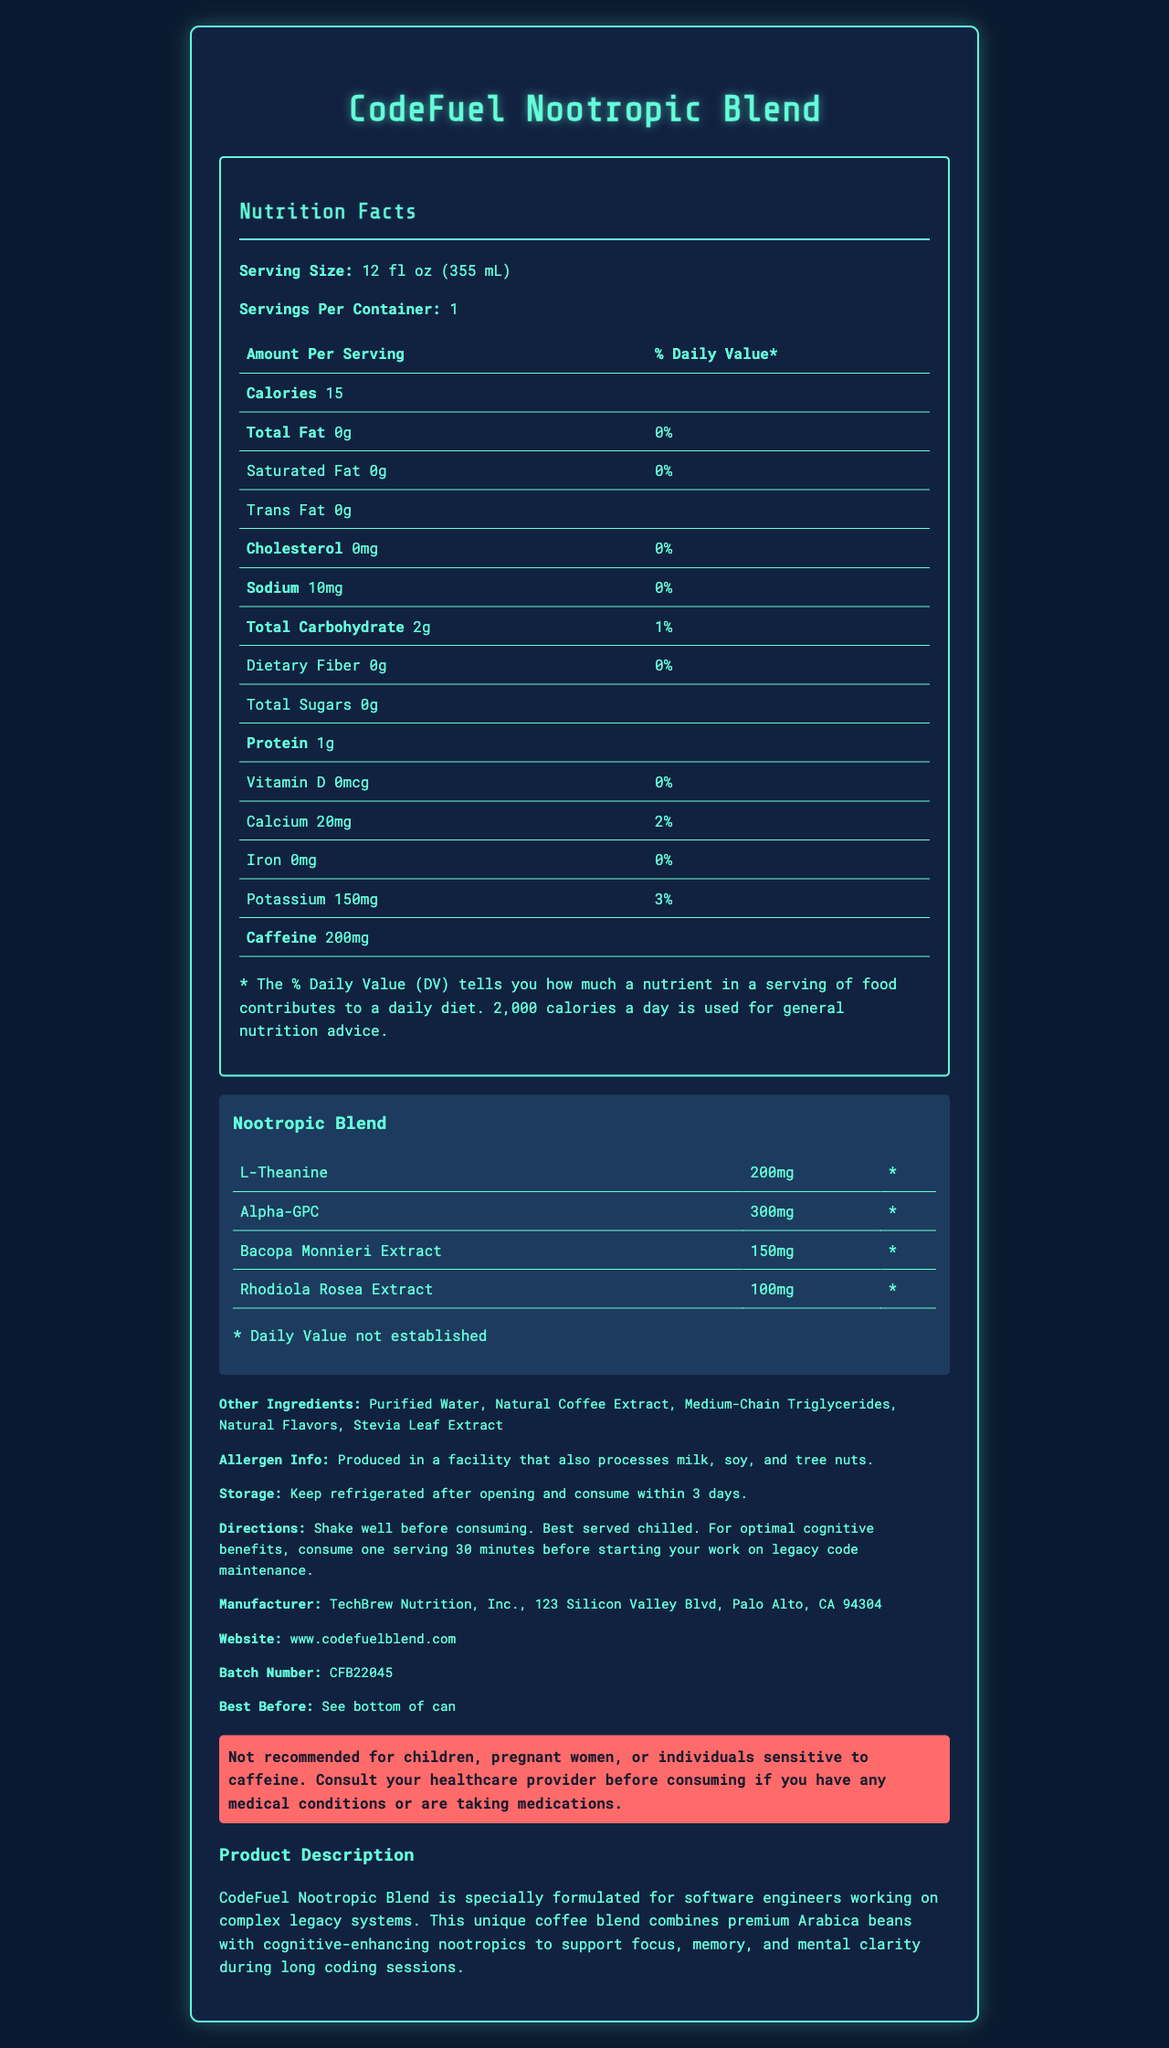what is the serving size? The serving size is stated as "12 fl oz (355 mL)" in the Nutrition Facts section.
Answer: 12 fl oz (355 mL) how many calories are in a serving? The document states that each serving has 15 calories.
Answer: 15 what is the amount of protein per serving? The Nutrition Facts section lists the protein content as 1g per serving.
Answer: 1g how much caffeine is in one serving? The document specifies that each serving contains 200mg of caffeine.
Answer: 200mg what is the sodium content per serving? The sodium content per serving is listed as 10mg in the Nutrition Facts section.
Answer: 10mg what is the daily value percentage for calcium? The Nutrition Facts table lists calcium as providing 2% of the Daily Value.
Answer: 2% which nootropic has the highest amount per serving? A. L-Theanine B. Alpha-GPC C. Bacopa Monnieri Extract D. Rhodiola Rosea Extract The document lists Alpha-GPC as having 300mg per serving, which is the highest amount among the nootropics.
Answer: B. Alpha-GPC which of the following ingredients are present in the CodeFuel Nootropic Blend? A. Purified Water B. Natural Coffee Extract C. Medium-Chain Triglycerides D. All of the above The section on "Other Ingredients" lists Purified Water, Natural Coffee Extract, and Medium-Chain Triglycerides among others.
Answer: D. All of the above is this product recommended for children? The warning section clearly states that the product is "Not recommended for children."
Answer: No how many servings are there per container? The Nutrition Facts indicate that there is 1 serving per container.
Answer: 1 what is the main idea of this document? The document provides detailed information on the nutritional content, ingredient list, and additional product information of the CodeFuel Nootropic Blend, highlighting its benefits for software engineers.
Answer: Description of the nutrition facts and ingredients of CodeFuel Nootropic Blend, a coffee formulated with cognitive-enhancing nootropics for software engineers. where can I find the best before date? The "Best Before" information is noted as being located on the bottom of the can.
Answer: See bottom of can what percentage of the daily value of dietary fiber does one serving provide? The Dietary Fiber section shows a 0% Daily Value for dietary fiber.
Answer: 0% who is the manufacturer of this product? The document lists TechBrew Nutrition, Inc. as the manufacturer.
Answer: TechBrew Nutrition, Inc. does this product contain any sugar? The Nutrition Facts section lists Total Sugars as 0g, indicating no sugar content in the product.
Answer: No how much Bacopa Monnieri Extract is in a serving? The document specifies that each serving contains 150mg of Bacopa Monnieri Extract.
Answer: 150mg what is the address of the manufacturer? The manufacturer's address is listed as 123 Silicon Valley Blvd, Palo Alto, CA 94304 in the document.
Answer: 123 Silicon Valley Blvd, Palo Alto, CA 94304 what additional steps should I take if I have medical conditions before consuming this product? The warning section advises individuals with medical conditions to consult their healthcare provider before consuming the product.
Answer: Consult your healthcare provider what is the website provided for more information? The document lists www.codefuelblend.com as the website for more information.
Answer: www.codefuelblend.com are the daily values for the nootropics established? The document indicates that the daily values for the nootropics are not established by marking them with an asterisk (*) and stating "* Daily Value not established."
Answer: No how should this product be stored after opening? The storage instructions state to keep the product refrigerated after opening and to consume it within 3 days.
Answer: Keep refrigerated after opening and consume within 3 days 